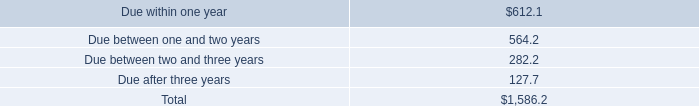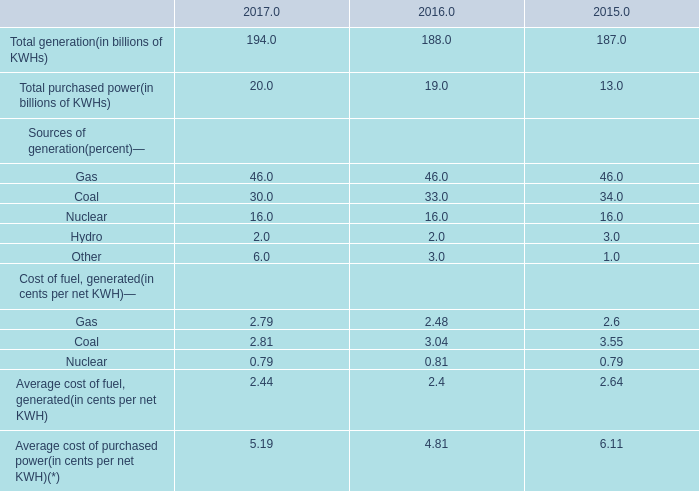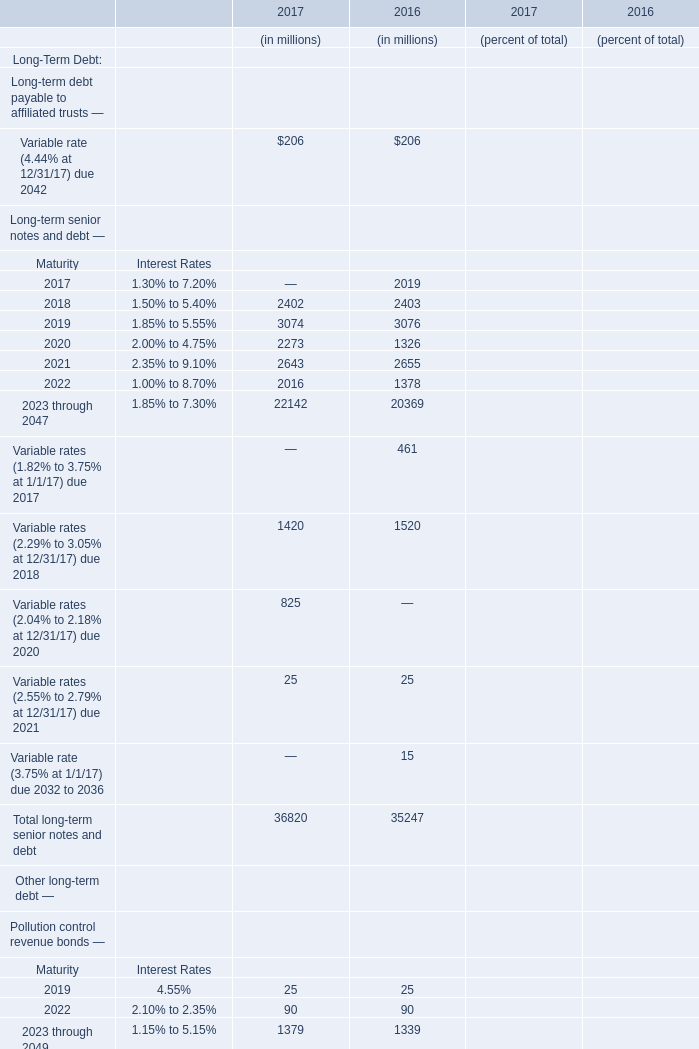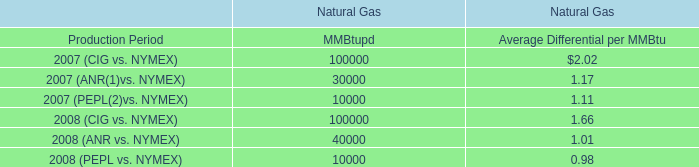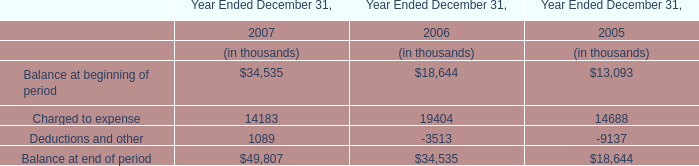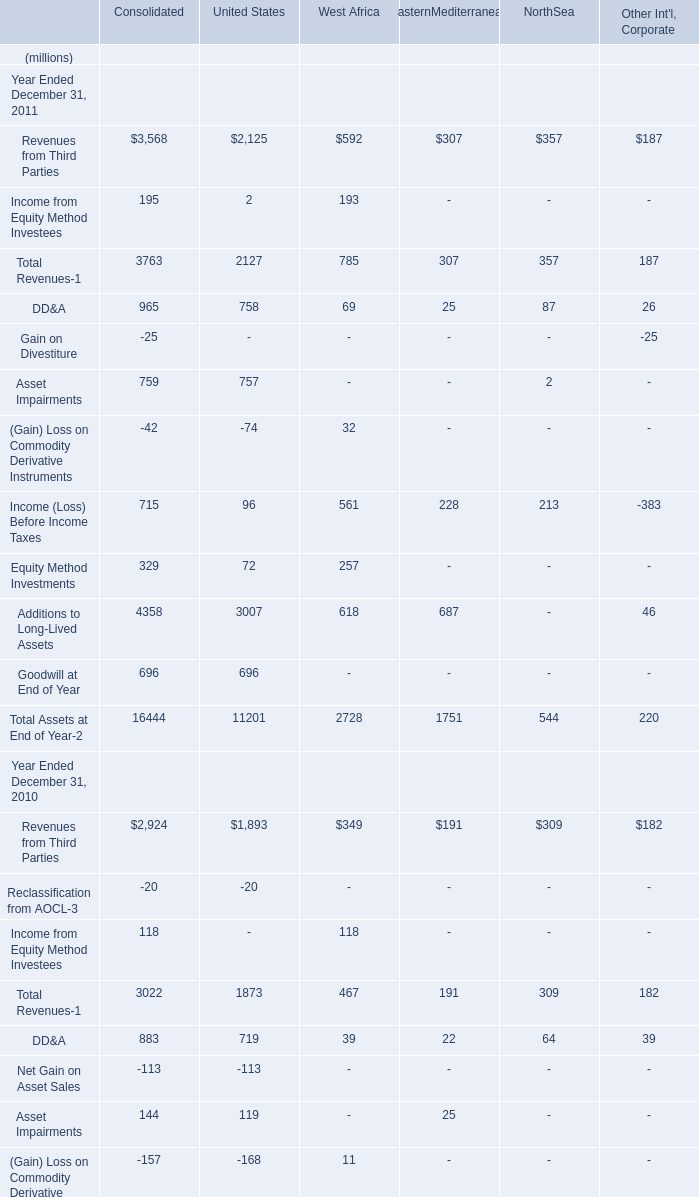As As the chart 2 shows,what is the value of Total long-term senior notes and debt in 2017? (in million) 
Answer: 36820. 